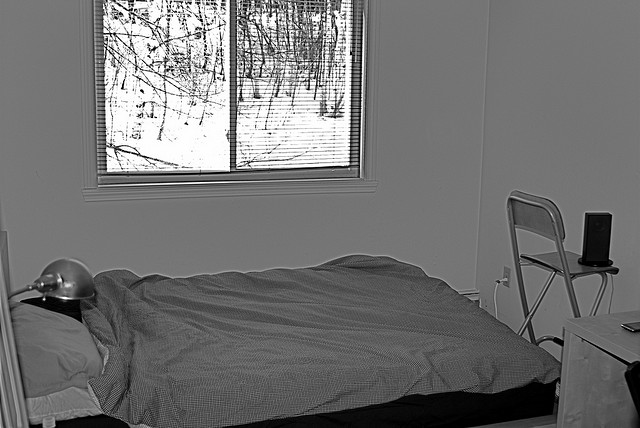<image>What shapes are patterned on the bedspread? I do not know the specific shapes pattern on the bedspread. It could be waffle weave, ripples, rectangles, lines, checks, checkered, or no specific shape at all. What shapes are patterned on the bedspread? I don't know what shapes are patterned on the bedspread. It can be seen 'waffle weave', 'ripples', 'rectangles', 'lines', 'checks', 'polka' or 'checkered'. 